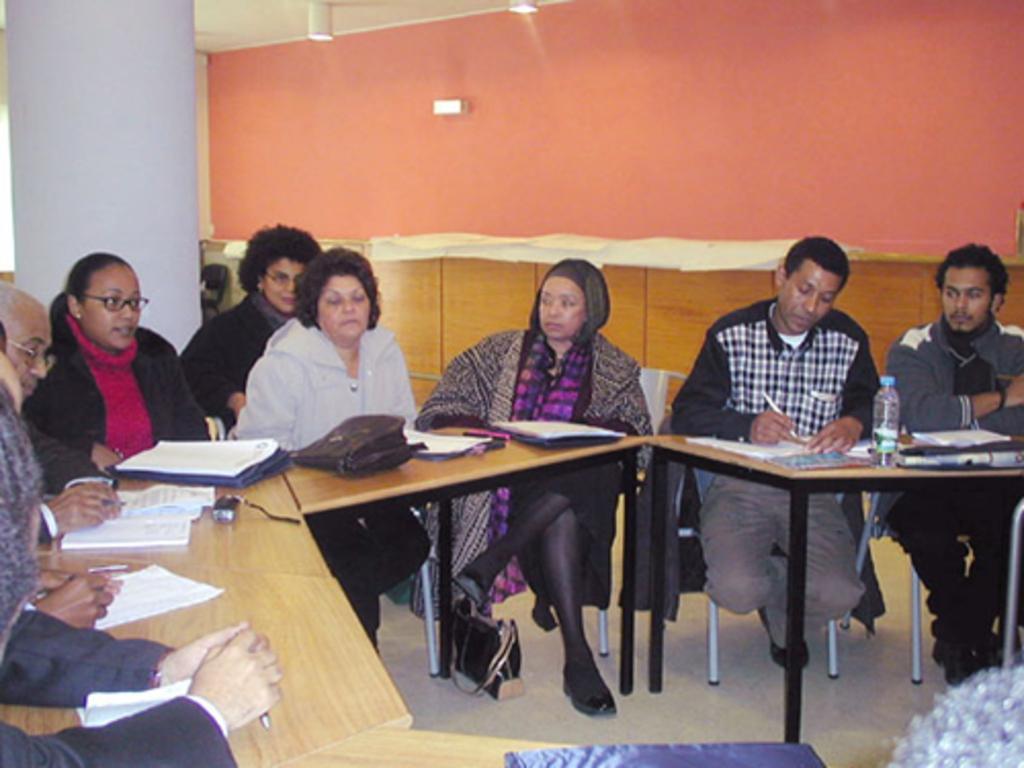In one or two sentences, can you explain what this image depicts? In this picture we can see group of peoples are sitting on the chairs in front of them we can see some books bags and bottle on the table, and there is a wall. 